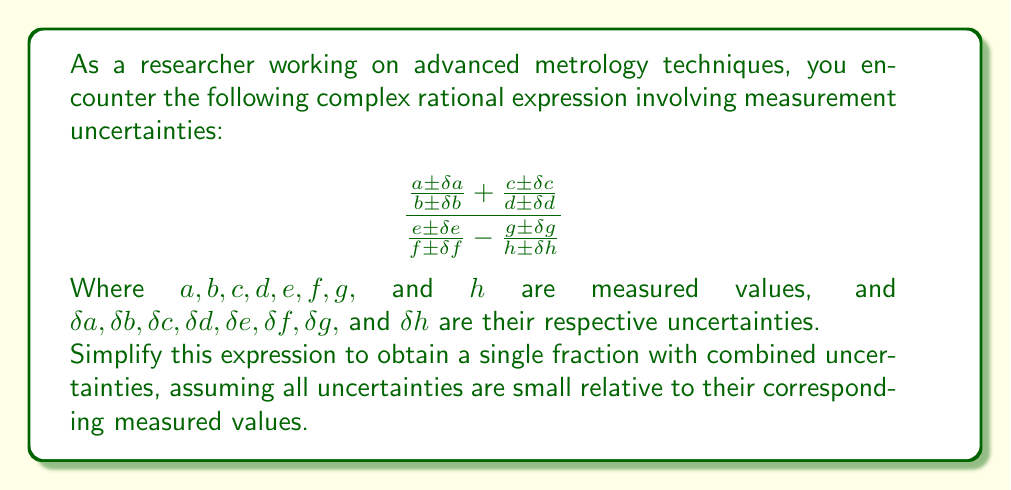Help me with this question. Let's approach this step-by-step:

1) First, we'll simplify the numerator and denominator separately.

2) For the numerator:
   $$\frac{a \pm \delta a}{b \pm \delta b} + \frac{c \pm \delta c}{d \pm \delta d}$$
   
   Using the approximation for division with small uncertainties:
   $$\frac{a \pm \delta a}{b \pm \delta b} \approx \frac{a}{b}\left(1 \pm \frac{\delta a}{a} \pm \frac{\delta b}{b}\right)$$
   $$\frac{c \pm \delta c}{d \pm \delta d} \approx \frac{c}{d}\left(1 \pm \frac{\delta c}{c} \pm \frac{\delta d}{d}\right)$$

   Adding these:
   $$\frac{a}{b}\left(1 \pm \frac{\delta a}{a} \pm \frac{\delta b}{b}\right) + \frac{c}{d}\left(1 \pm \frac{\delta c}{c} \pm \frac{\delta d}{d}\right)$$
   $$= \frac{ad + bc}{bd} \pm \frac{ad}{bd}\left(\frac{\delta a}{a} + \frac{\delta b}{b}\right) \pm \frac{bc}{bd}\left(\frac{\delta c}{c} + \frac{\delta d}{d}\right)$$

3) For the denominator:
   $$\frac{e \pm \delta e}{f \pm \delta f} - \frac{g \pm \delta g}{h \pm \delta h}$$
   
   Similarly:
   $$\frac{e}{f}\left(1 \pm \frac{\delta e}{e} \pm \frac{\delta f}{f}\right) - \frac{g}{h}\left(1 \pm \frac{\delta g}{g} \pm \frac{\delta h}{h}\right)$$
   $$= \frac{eh - fg}{fh} \pm \frac{eh}{fh}\left(\frac{\delta e}{e} + \frac{\delta f}{f}\right) \pm \frac{fg}{fh}\left(\frac{\delta g}{g} + \frac{\delta h}{h}\right)$$

4) Now, we can write the entire expression as:

   $$\frac{\frac{ad + bc}{bd} \pm \frac{ad}{bd}\left(\frac{\delta a}{a} + \frac{\delta b}{b}\right) \pm \frac{bc}{bd}\left(\frac{\delta c}{c} + \frac{\delta d}{d}\right)}{\frac{eh - fg}{fh} \pm \frac{eh}{fh}\left(\frac{\delta e}{e} + \frac{\delta f}{f}\right) \pm \frac{fg}{fh}\left(\frac{\delta g}{g} + \frac{\delta h}{h}\right)}$$

5) Using the approximation for division with small uncertainties again:

   $$\frac{(ad + bc)fh}{(eh - fg)bd} \pm \frac{(ad + bc)fh}{(eh - fg)bd}\left(\frac{ad}{ad+bc}\left(\frac{\delta a}{a} + \frac{\delta b}{b}\right) + \frac{bc}{ad+bc}\left(\frac{\delta c}{c} + \frac{\delta d}{d}\right) + \frac{eh}{eh-fg}\left(\frac{\delta e}{e} + \frac{\delta f}{f}\right) + \frac{fg}{eh-fg}\left(\frac{\delta g}{g} + \frac{\delta h}{h}\right)\right)$$

This is the simplified expression with combined uncertainties.
Answer: $$\frac{(ad + bc)fh}{(eh - fg)bd} \pm \frac{(ad + bc)fh}{(eh - fg)bd}\left(\frac{ad}{ad+bc}\left(\frac{\delta a}{a} + \frac{\delta b}{b}\right) + \frac{bc}{ad+bc}\left(\frac{\delta c}{c} + \frac{\delta d}{d}\right) + \frac{eh}{eh-fg}\left(\frac{\delta e}{e} + \frac{\delta f}{f}\right) + \frac{fg}{eh-fg}\left(\frac{\delta g}{g} + \frac{\delta h}{h}\right)\right)$$ 